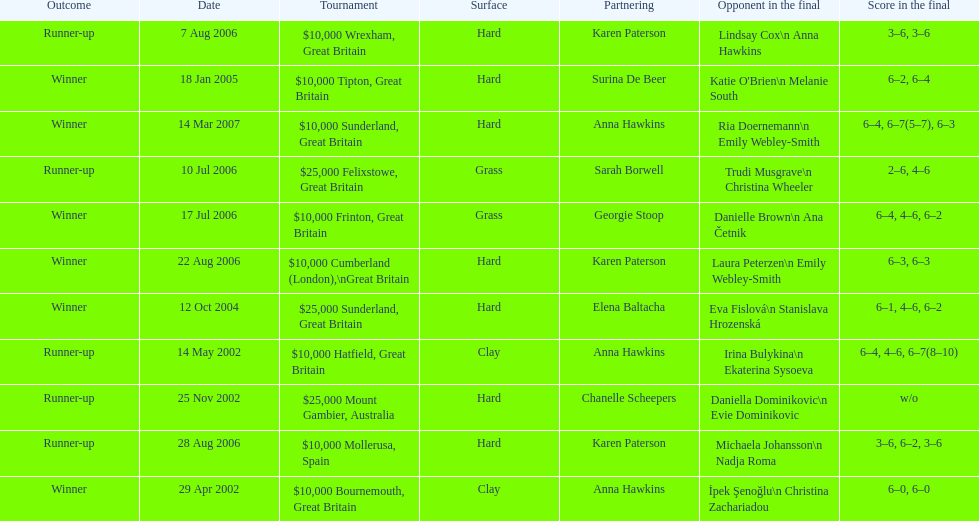How many were played on a hard surface? 7. 